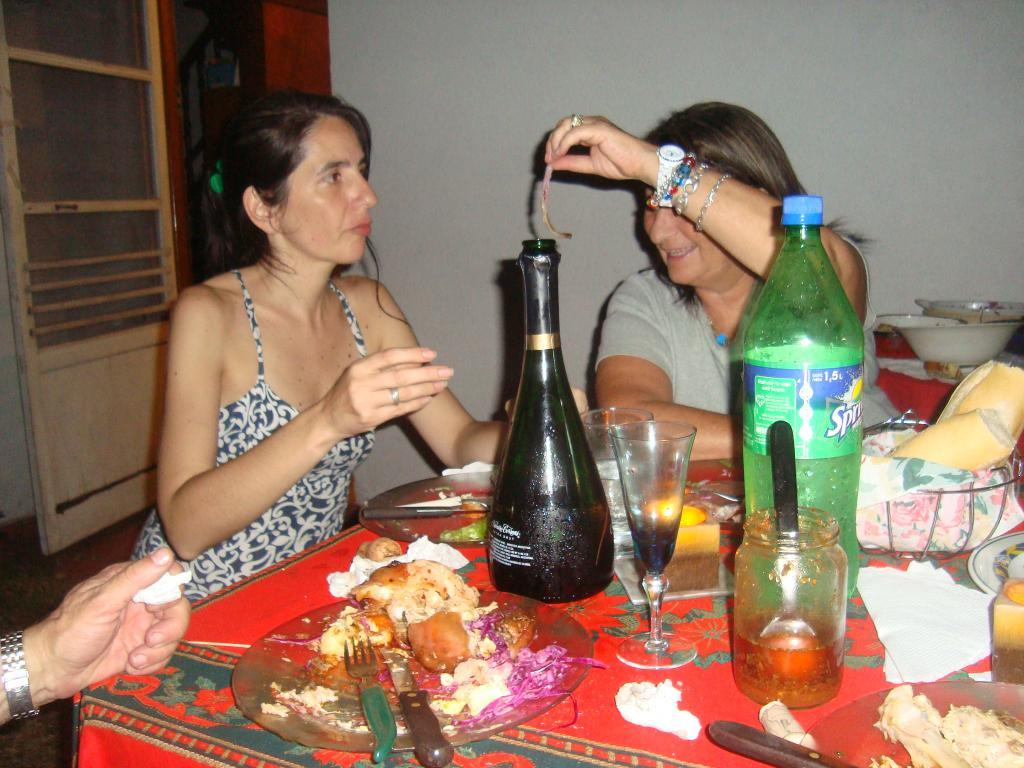How many women are present in the image? There are two women in the image. What are the women doing in the image? The women are sitting on a table. What else can be seen on the table besides the women? There are food items and a Sprite bottle on the table. What type of plastic is used to make the trucks in the image? There are no trucks present in the image; it features two women sitting on a table with food items and a Sprite bottle. 